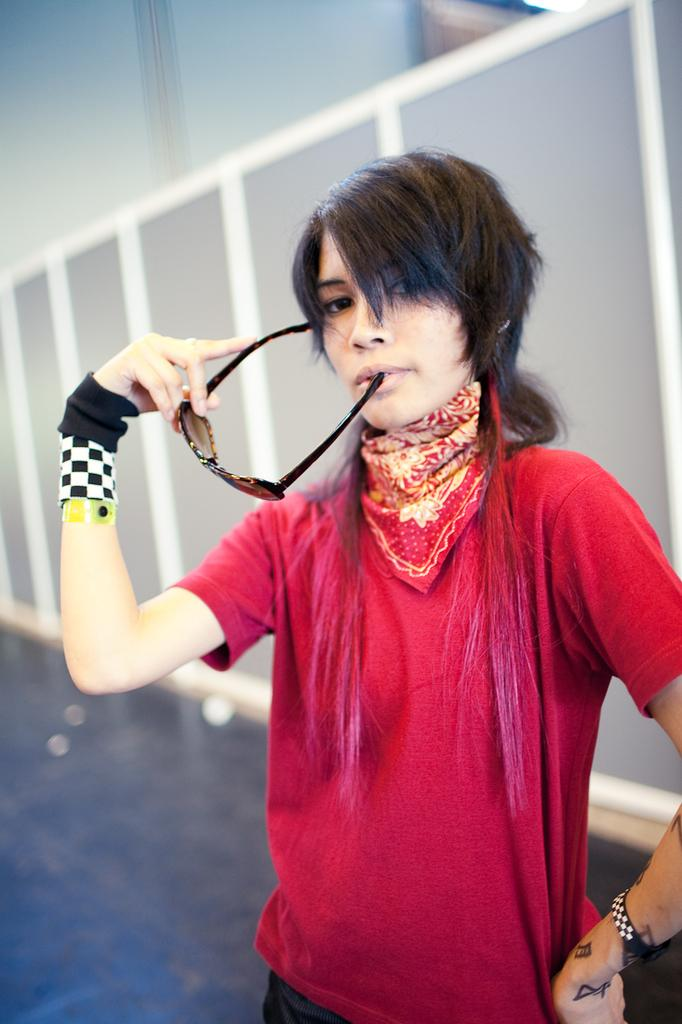Who is the main subject in the picture? There is a woman in the picture. What is the woman wearing? The woman is wearing a red T-shirt. What is the woman holding in the picture? The woman is holding spectacles. How many trees can be seen in the picture? There are no trees visible in the picture; it features a woman wearing a red T-shirt and holding spectacles. What type of iron is being used by the woman in the picture? There is no iron present in the picture; the woman is holding spectacles. 